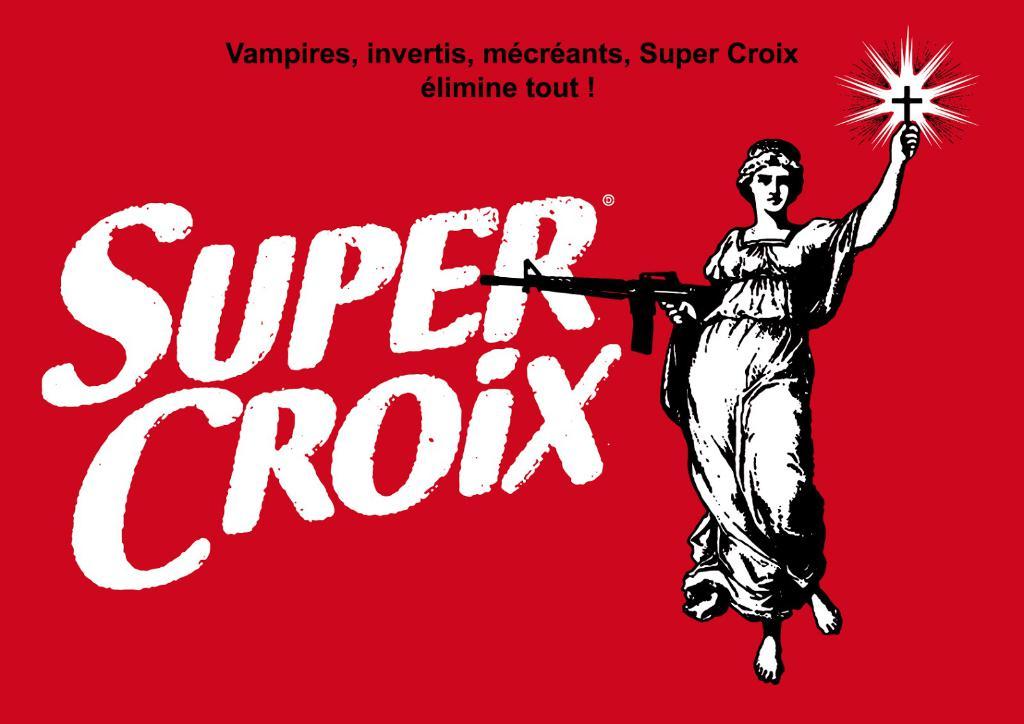Does the super croix claim to ward off vampires?
Ensure brevity in your answer.  Yes. What is the name of the cross she is holding up?
Ensure brevity in your answer.  Super croix. 